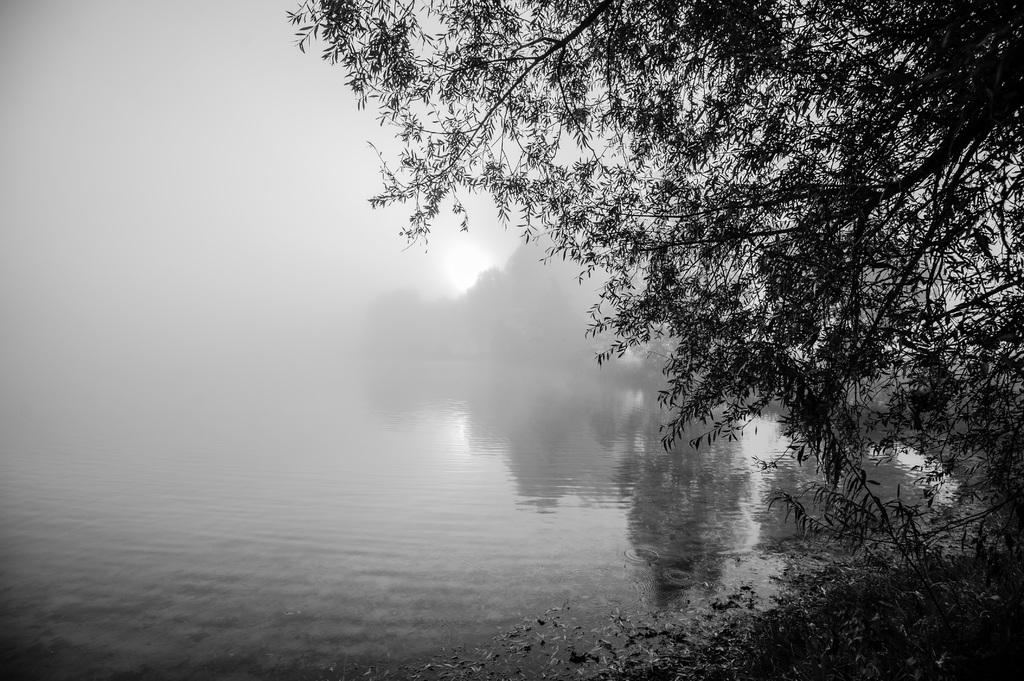What is present at the bottom of the image? There is water at the bottom of the image. What type of vegetation can be seen on the right side of the image? There are trees on the right side of the image. What is visible at the top of the image? The sky is visible at the top of the image. How would you describe the appearance of the sky in the image? The sky appears to be foggy in the image. How does the expert unlock the door in the image? There is no expert or door present in the image; it features water, trees, and a foggy sky. 